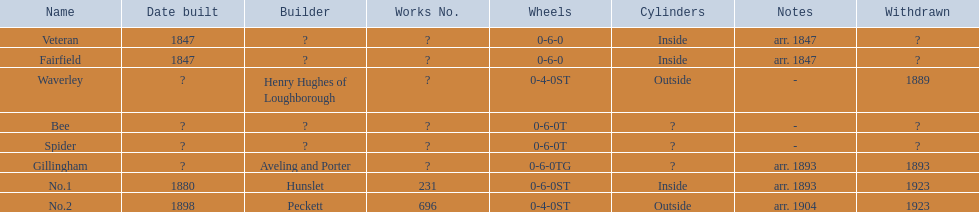What are the aldernay railroads? Veteran, Fairfield, Waverley, Bee, Spider, Gillingham, No.1, No.2. Which ones were constructed in 1847? Veteran, Fairfield. Of those, which one is not fairfield? Veteran. 